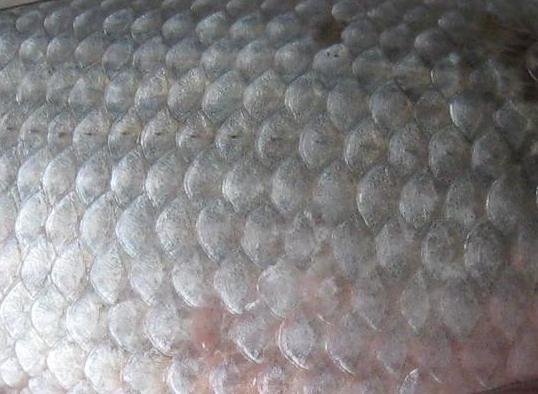Texture is defined as the feel, appearance, or consistency of a surface or substance from a human's perspective. Detect all the textures in the image. Present it as a comma separated list. The image clearly showcases a variety of textures which include smooth, glossy, and overlapping textures. The smooth texture is evident in the flat surfaces of the individual scales, indicative of a silky feel under the fingertips. The glossiness is highlighted by the reflective sheen on the scales, suggesting a sleek and perhaps moist texture which is typical for aquatic living beings. Additionally, the scales exhibit an overlapping arrangement, presenting a three-dimensional and ridged tactile experience. These observations provide insights into a detailed, tactile understanding of the image's subject matter. 